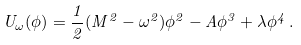Convert formula to latex. <formula><loc_0><loc_0><loc_500><loc_500>U _ { \omega } ( \phi ) = \frac { 1 } { 2 } ( M ^ { 2 } - \omega ^ { 2 } ) \phi ^ { 2 } - A \phi ^ { 3 } + \lambda \phi ^ { 4 } \, .</formula> 